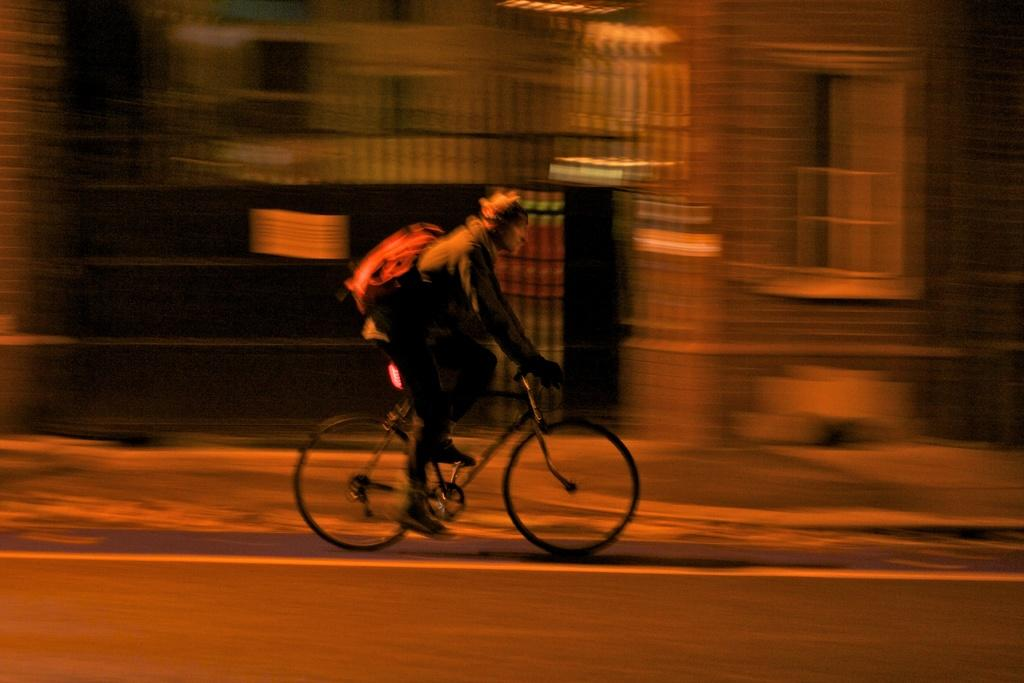What is the main subject of the image? There is a person in the image. What is the person doing in the image? The person is riding a bicycle. Can you describe the background of the image? The background of the image is blurred. How many fingers can be seen on the dolls in the image? There are no dolls present in the image, so it is not possible to determine the number of fingers on any dolls. 